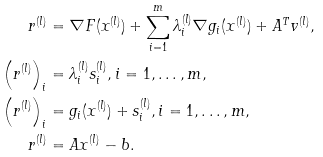<formula> <loc_0><loc_0><loc_500><loc_500>r ^ { ( l ) } & = \nabla F ( x ^ { ( l ) } ) + \sum _ { i = 1 } ^ { m } \lambda ^ { ( l ) } _ { i } \nabla g _ { i } ( x ^ { ( l ) } ) + A ^ { T } v ^ { ( l ) } , \\ \left ( r ^ { ( l ) } \right ) _ { i } & = \lambda ^ { ( l ) } _ { i } s _ { i } ^ { ( l ) } , i = 1 , \dots , m , \\ \left ( r ^ { ( l ) } \right ) _ { i } & = g _ { i } ( x ^ { ( l ) } ) + s _ { i } ^ { ( l ) } , i = 1 , \dots , m , \\ r ^ { ( l ) } & = A x ^ { ( l ) } - b .</formula> 